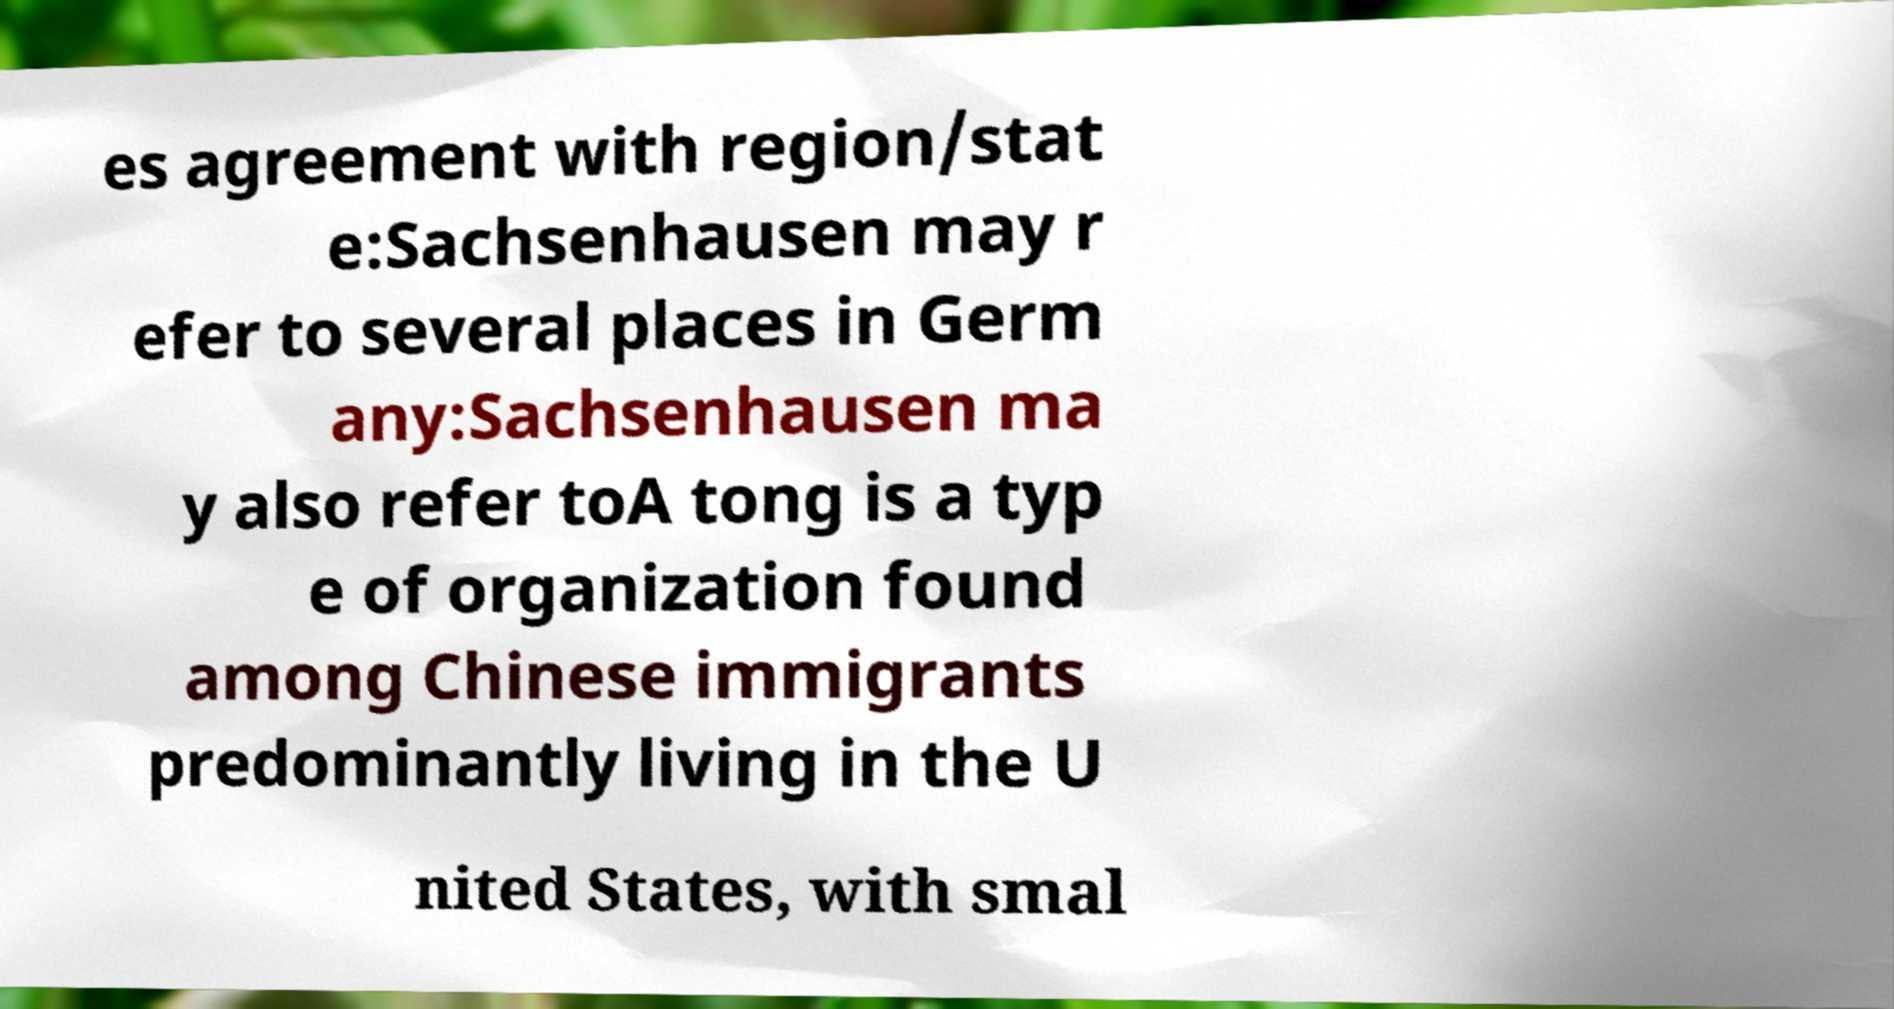Please read and relay the text visible in this image. What does it say? es agreement with region/stat e:Sachsenhausen may r efer to several places in Germ any:Sachsenhausen ma y also refer toA tong is a typ e of organization found among Chinese immigrants predominantly living in the U nited States, with smal 